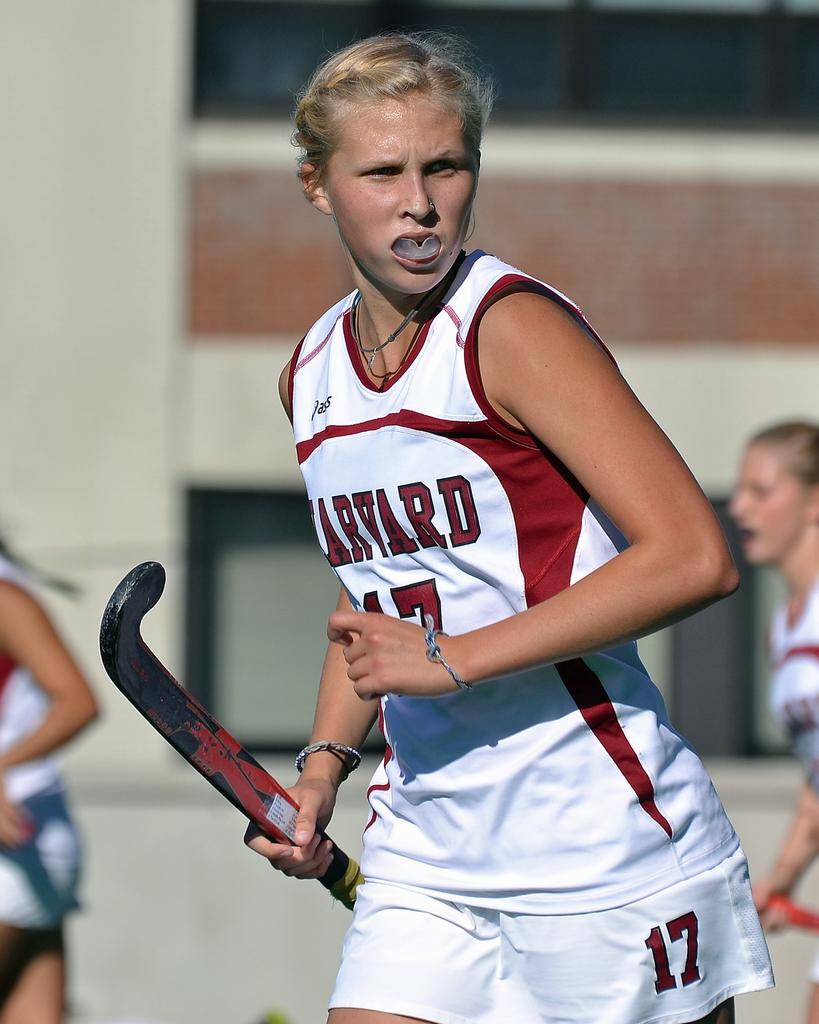Provide a one-sentence caption for the provided image. A Harvard hockey player is looking away from the ground. 